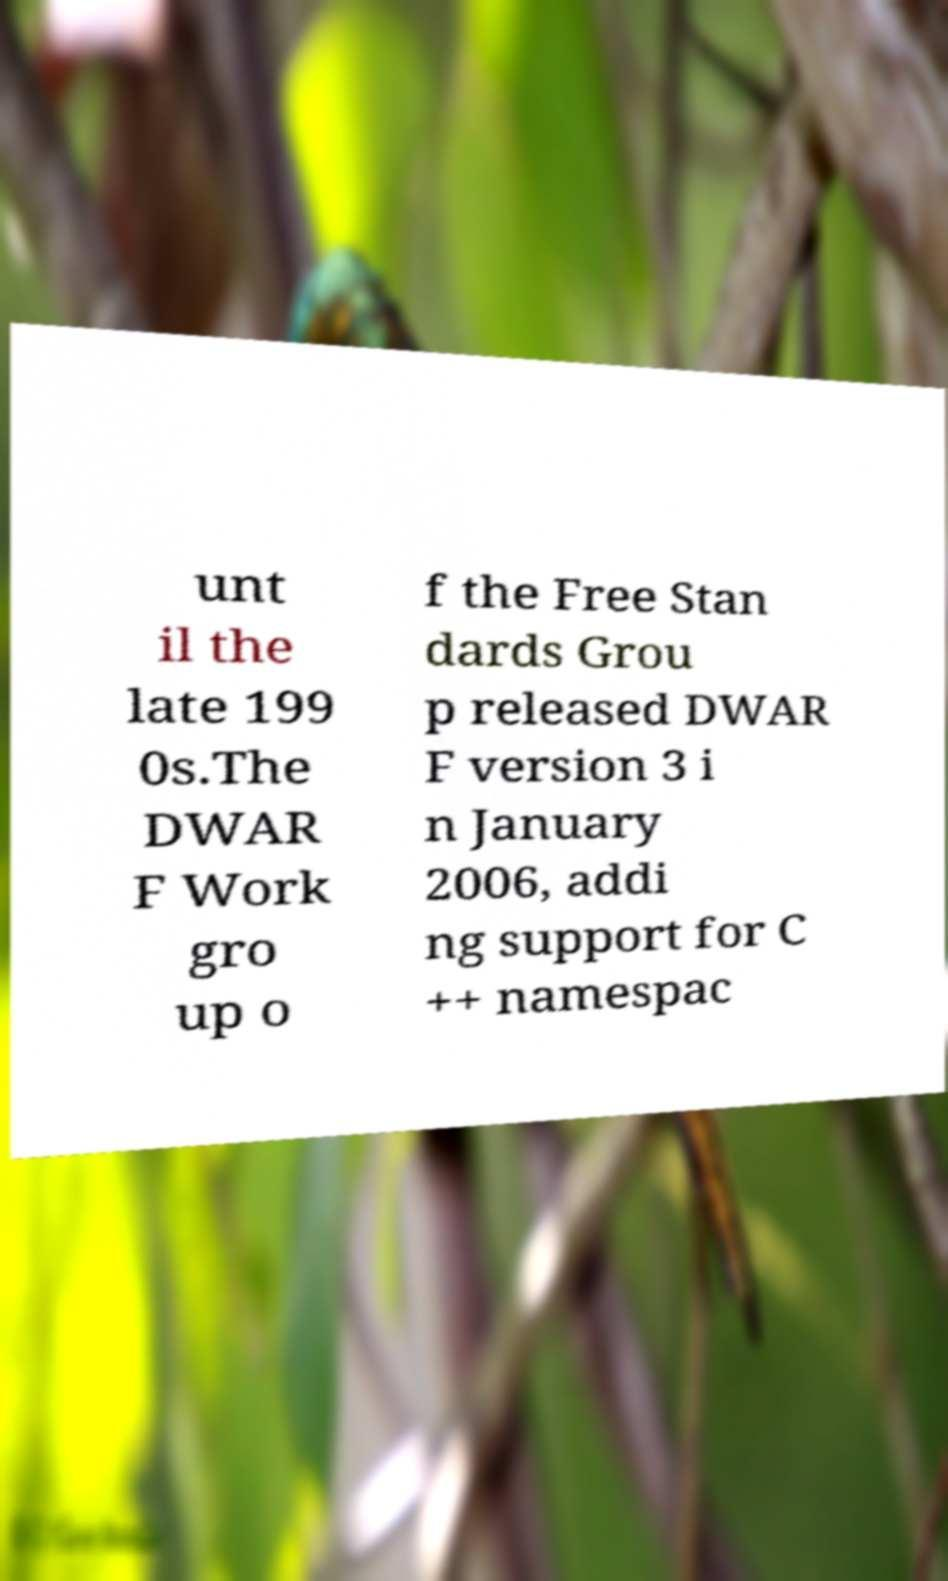What messages or text are displayed in this image? I need them in a readable, typed format. unt il the late 199 0s.The DWAR F Work gro up o f the Free Stan dards Grou p released DWAR F version 3 i n January 2006, addi ng support for C ++ namespac 